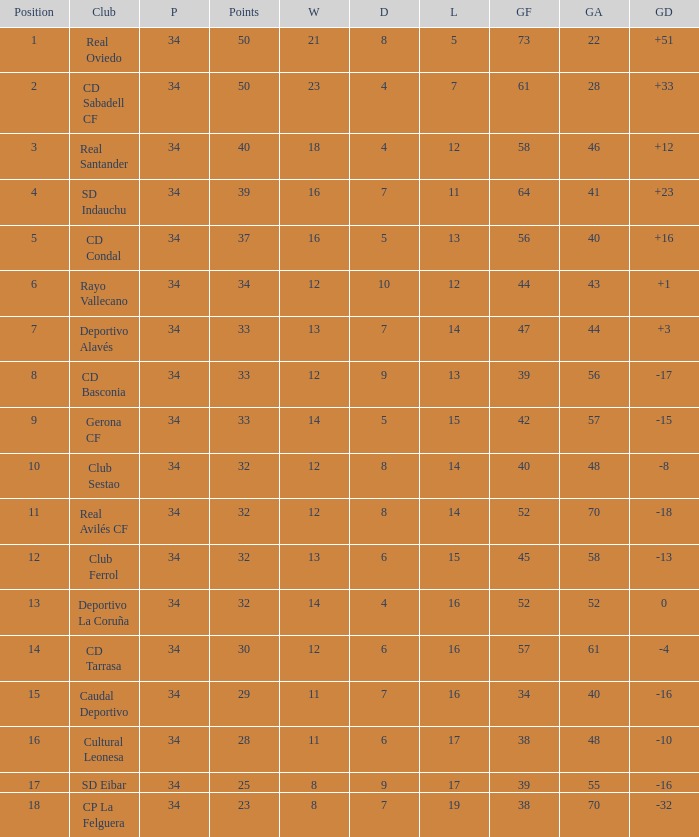How many Goals against have Played more than 34? 0.0. 